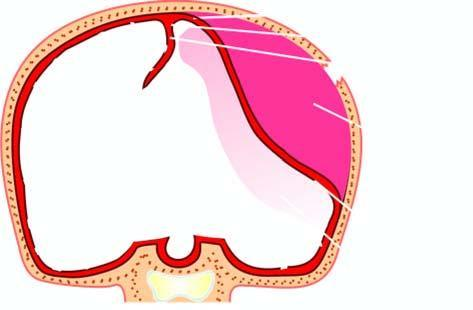does epidural haematoma result from rupture of artery following skull fracture resulting in accumulation of arterial blood between the skull and the dura?
Answer the question using a single word or phrase. Yes 